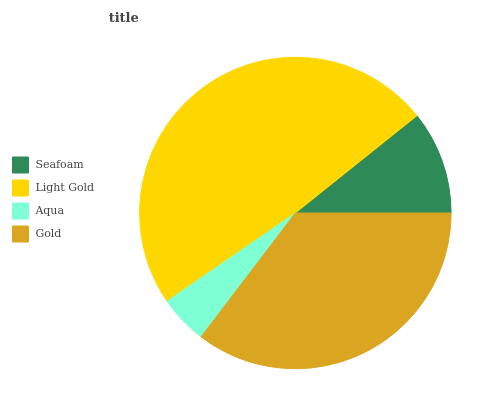Is Aqua the minimum?
Answer yes or no. Yes. Is Light Gold the maximum?
Answer yes or no. Yes. Is Light Gold the minimum?
Answer yes or no. No. Is Aqua the maximum?
Answer yes or no. No. Is Light Gold greater than Aqua?
Answer yes or no. Yes. Is Aqua less than Light Gold?
Answer yes or no. Yes. Is Aqua greater than Light Gold?
Answer yes or no. No. Is Light Gold less than Aqua?
Answer yes or no. No. Is Gold the high median?
Answer yes or no. Yes. Is Seafoam the low median?
Answer yes or no. Yes. Is Light Gold the high median?
Answer yes or no. No. Is Light Gold the low median?
Answer yes or no. No. 